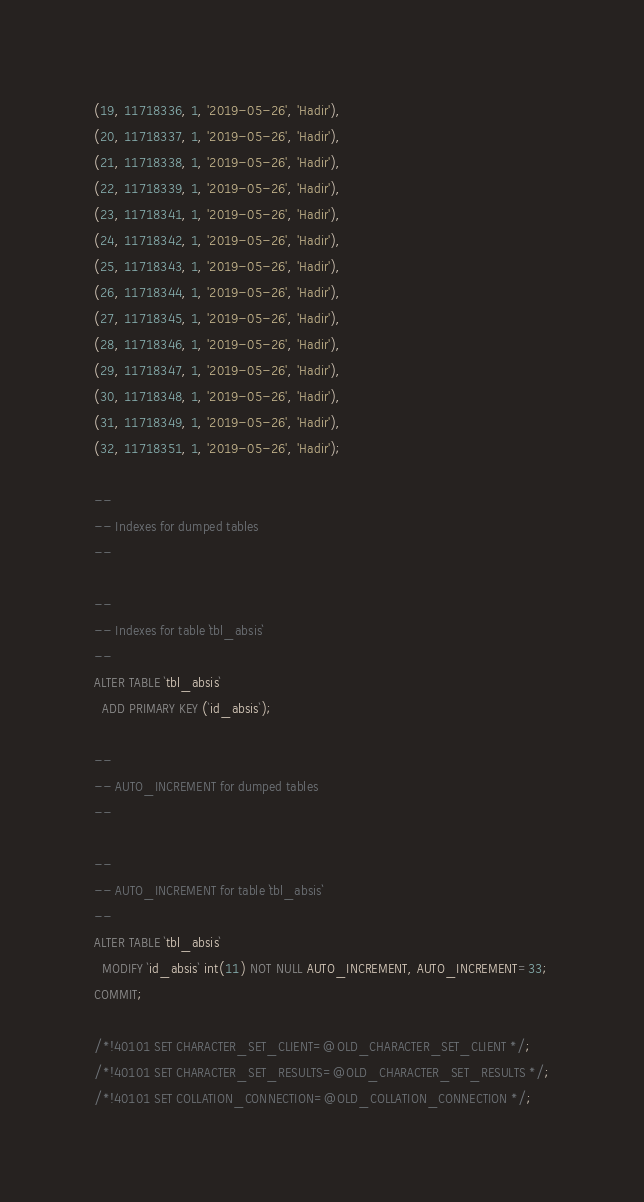Convert code to text. <code><loc_0><loc_0><loc_500><loc_500><_SQL_>(19, 11718336, 1, '2019-05-26', 'Hadir'),
(20, 11718337, 1, '2019-05-26', 'Hadir'),
(21, 11718338, 1, '2019-05-26', 'Hadir'),
(22, 11718339, 1, '2019-05-26', 'Hadir'),
(23, 11718341, 1, '2019-05-26', 'Hadir'),
(24, 11718342, 1, '2019-05-26', 'Hadir'),
(25, 11718343, 1, '2019-05-26', 'Hadir'),
(26, 11718344, 1, '2019-05-26', 'Hadir'),
(27, 11718345, 1, '2019-05-26', 'Hadir'),
(28, 11718346, 1, '2019-05-26', 'Hadir'),
(29, 11718347, 1, '2019-05-26', 'Hadir'),
(30, 11718348, 1, '2019-05-26', 'Hadir'),
(31, 11718349, 1, '2019-05-26', 'Hadir'),
(32, 11718351, 1, '2019-05-26', 'Hadir');

--
-- Indexes for dumped tables
--

--
-- Indexes for table `tbl_absis`
--
ALTER TABLE `tbl_absis`
  ADD PRIMARY KEY (`id_absis`);

--
-- AUTO_INCREMENT for dumped tables
--

--
-- AUTO_INCREMENT for table `tbl_absis`
--
ALTER TABLE `tbl_absis`
  MODIFY `id_absis` int(11) NOT NULL AUTO_INCREMENT, AUTO_INCREMENT=33;
COMMIT;

/*!40101 SET CHARACTER_SET_CLIENT=@OLD_CHARACTER_SET_CLIENT */;
/*!40101 SET CHARACTER_SET_RESULTS=@OLD_CHARACTER_SET_RESULTS */;
/*!40101 SET COLLATION_CONNECTION=@OLD_COLLATION_CONNECTION */;
</code> 